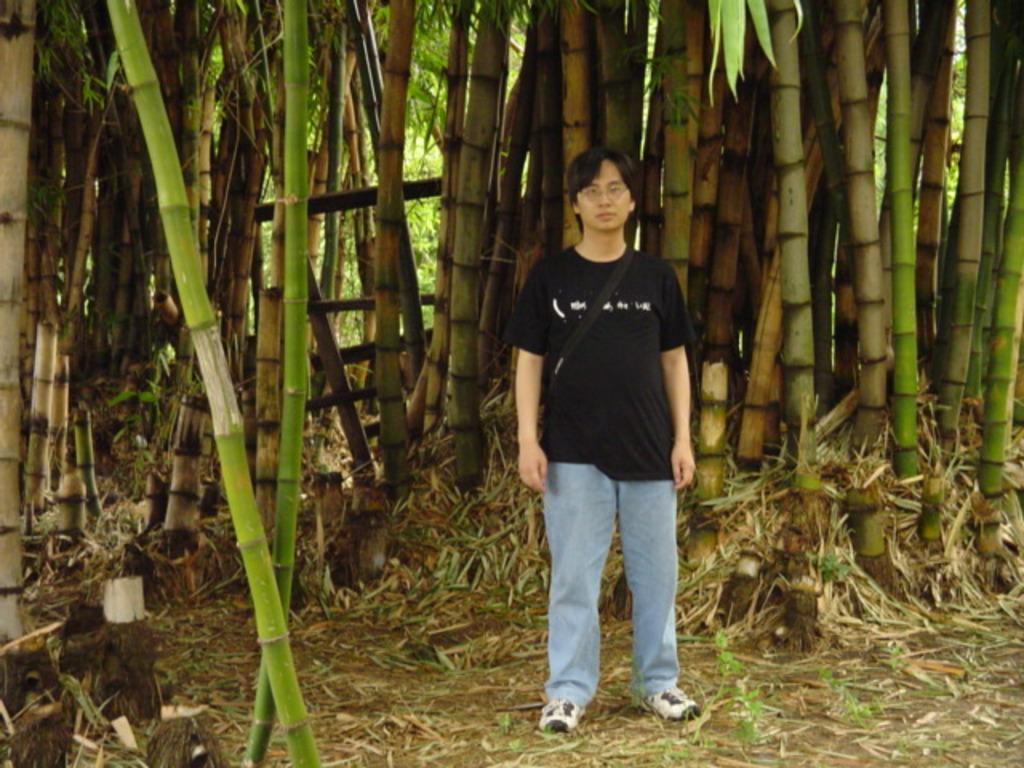In one or two sentences, can you explain what this image depicts? In this picture there is a man in the center of the image and there are trees in the background area of the image. 